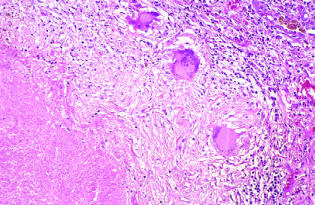does the granulomatous response take the form of a three-dimensional sphere with the offending organism in the central area?
Answer the question using a single word or phrase. Yes 